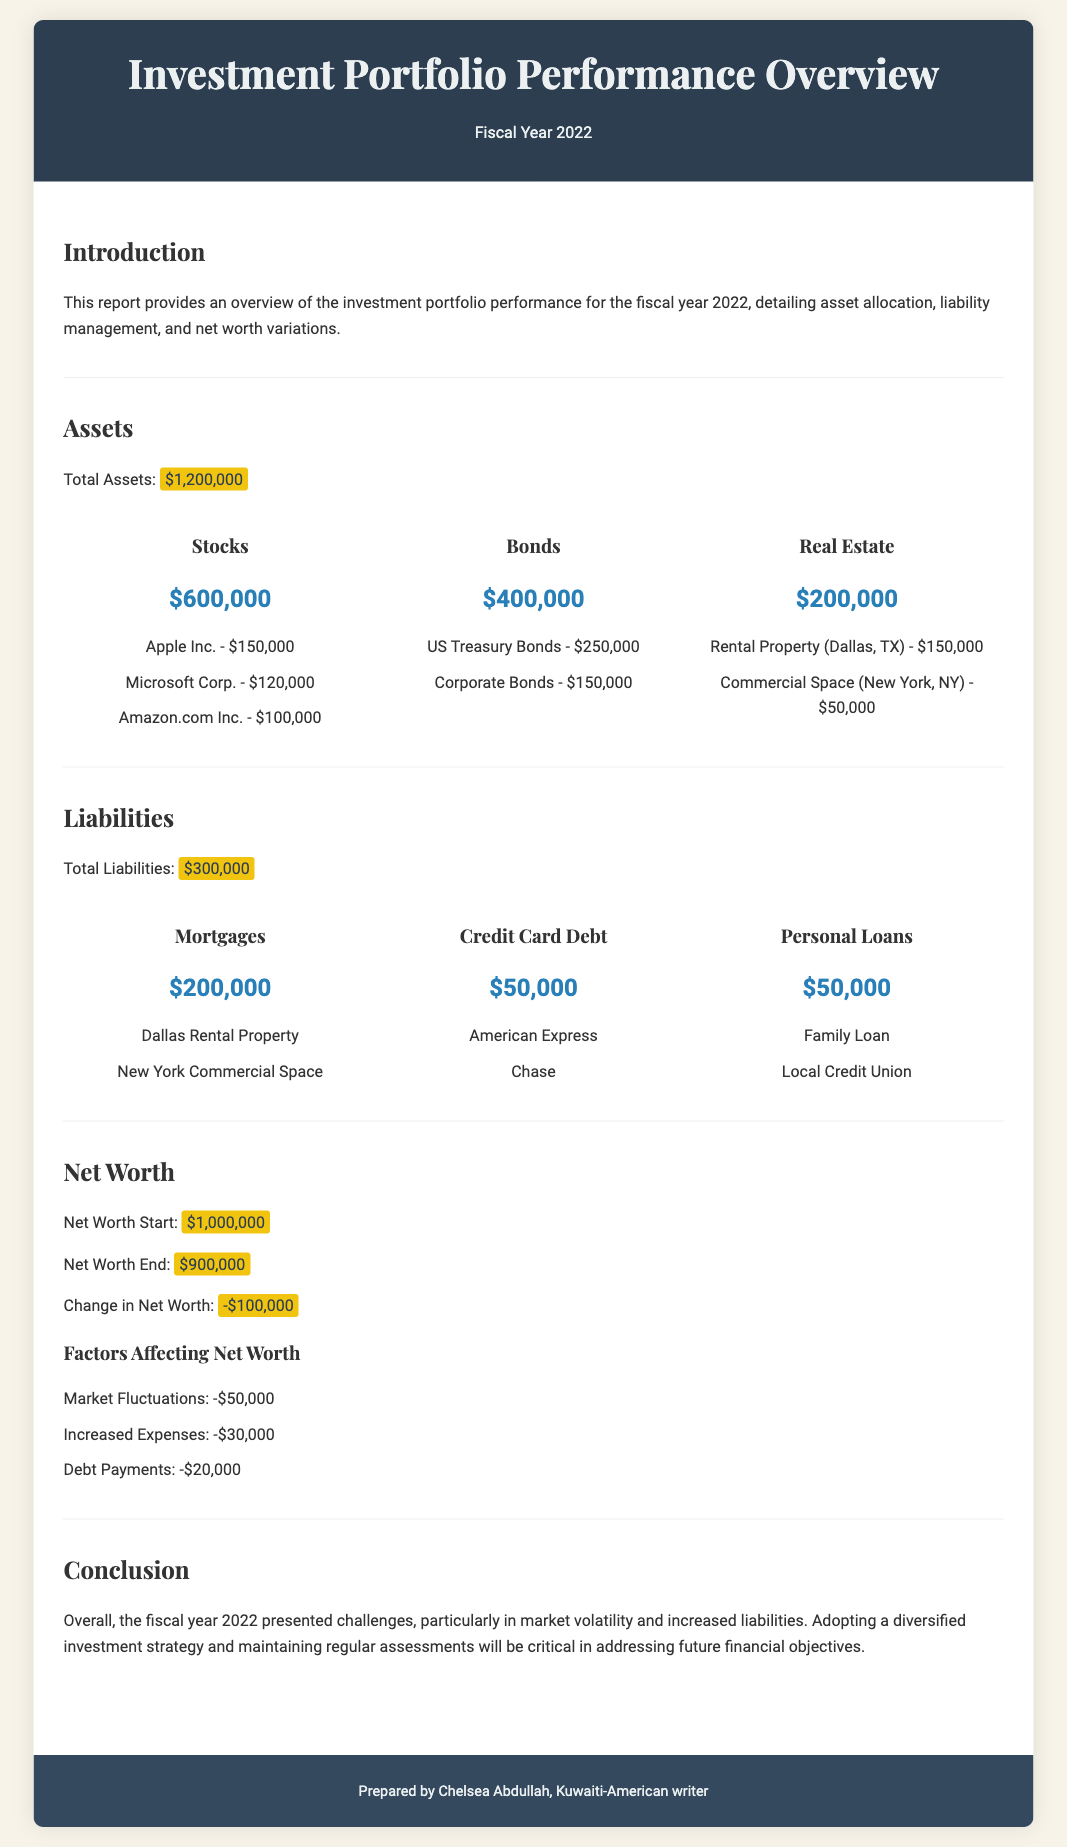What is the total assets? The total assets are listed in the document as $1,200,000.
Answer: $1,200,000 What is the total liabilities? The total liabilities stated in the report are $300,000.
Answer: $300,000 What is the net worth at the start of the year? The net worth at the start of the year is marked as $1,000,000.
Answer: $1,000,000 What is the net worth at the end of the year? The net worth at the end of the year is indicated as $900,000.
Answer: $900,000 What was the change in net worth? The document specifies that the change in net worth was -$100,000.
Answer: -$100,000 How much was lost due to market fluctuations? The losses attributed to market fluctuations are stated as -$50,000.
Answer: -$50,000 What percentage of total assets is made up of stocks? Stocks make up $600,000 out of total assets of $1,200,000, which is 50%.
Answer: 50% How many mortgages are listed under liabilities? The liabilities section lists two mortgages under the chart for mortgages.
Answer: Two What type of report is this document? This document is an investment portfolio performance overview.
Answer: Investment portfolio performance overview What was the total amount of credit card debt? The total credit card debt mentioned in the document is $50,000.
Answer: $50,000 